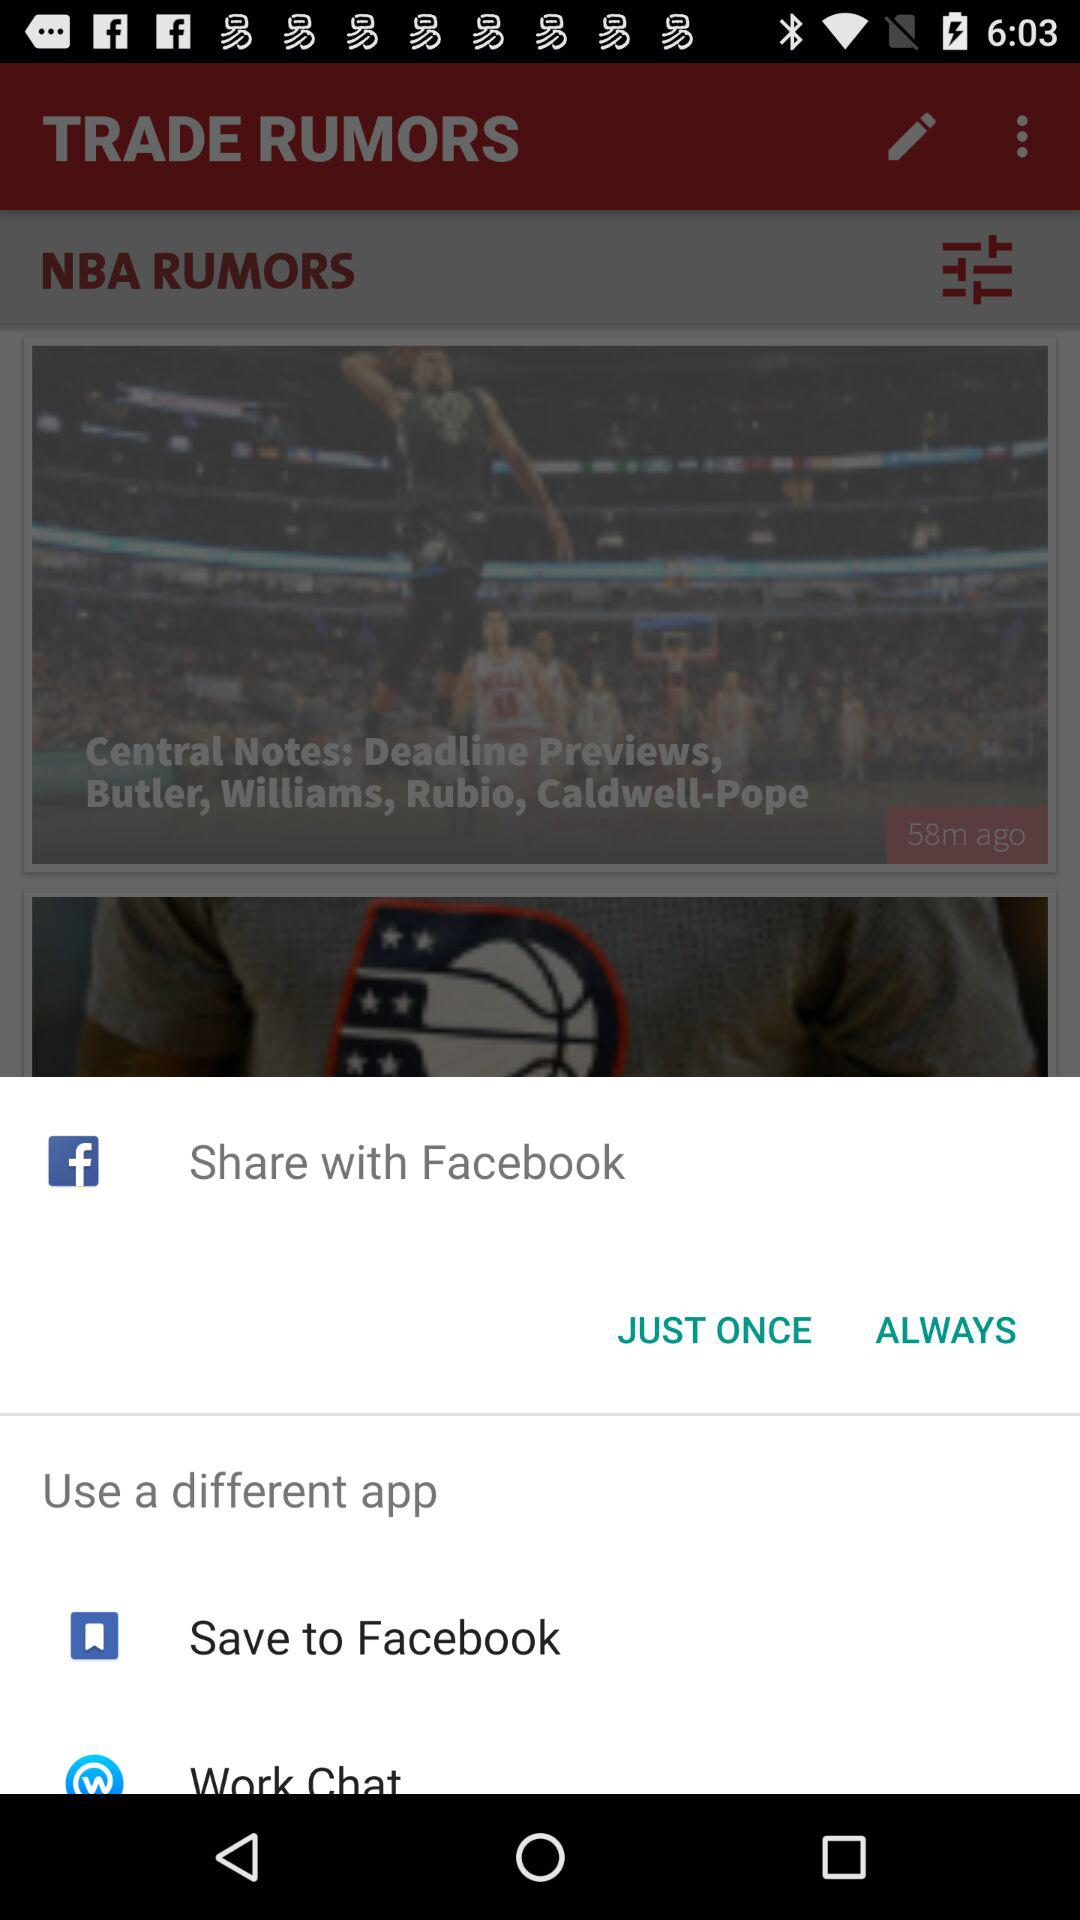Which app can we use to share? You can use "Facebook", "Save to Facebook" and "Work Chat" apps to share. 